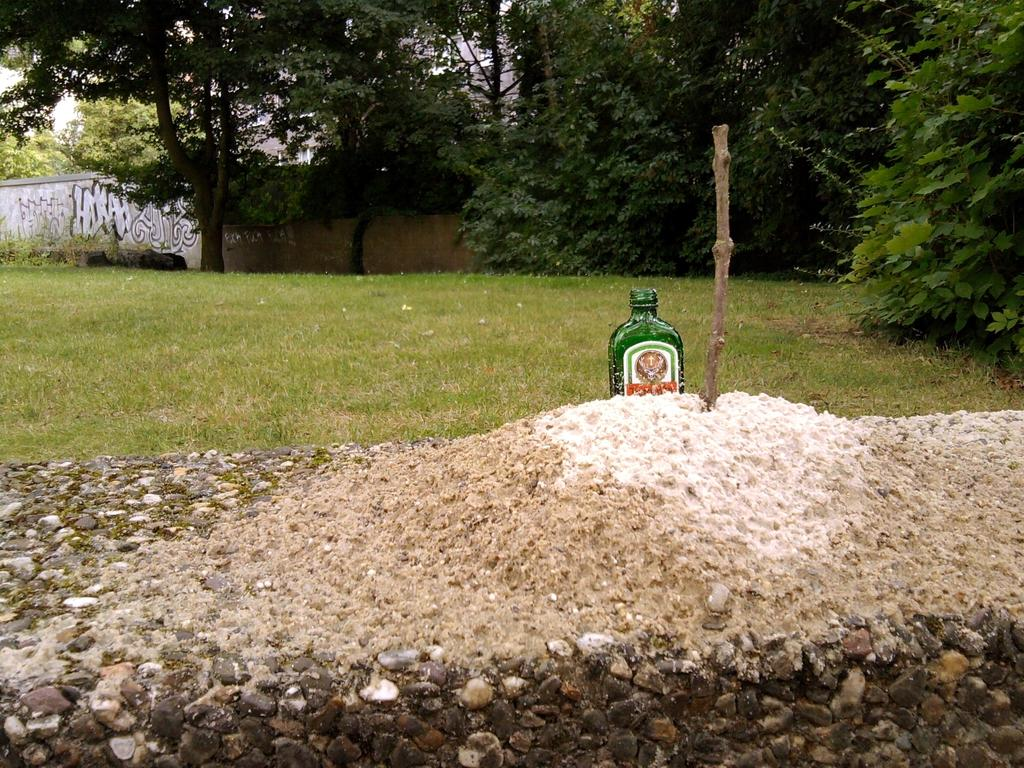What object is in the image that is made of glass? There is a glass bottle in the image. What is the glass bottle placed on or in? The glass bottle is in sand. What can be seen in the background of the image? There are trees and a wall in the background of the image. How does the glass bottle say good-bye to the trees in the image? The glass bottle does not have the ability to say good-bye, as it is an inanimate object. 